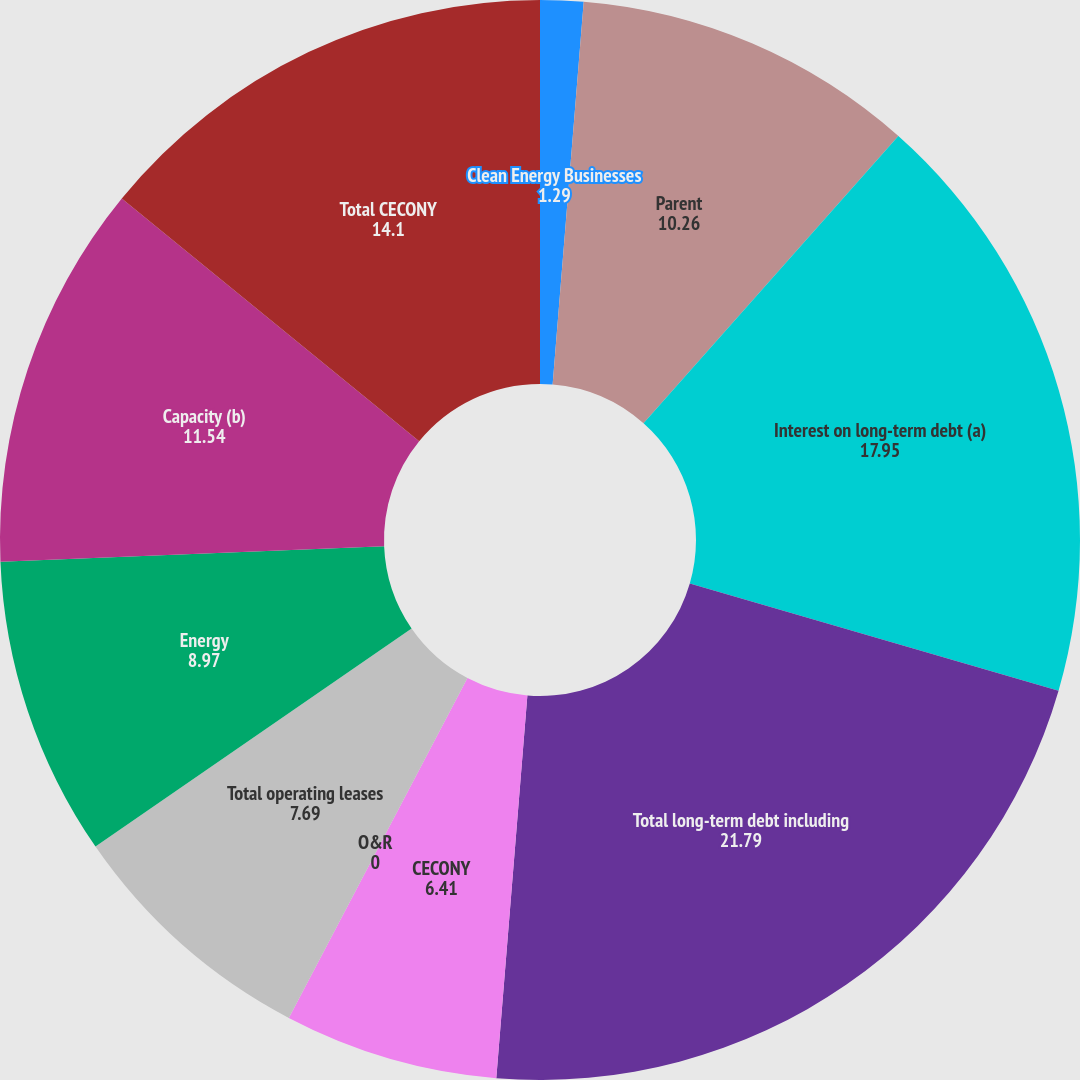<chart> <loc_0><loc_0><loc_500><loc_500><pie_chart><fcel>Clean Energy Businesses<fcel>Parent<fcel>Interest on long-term debt (a)<fcel>Total long-term debt including<fcel>CECONY<fcel>O&R<fcel>Total operating leases<fcel>Energy<fcel>Capacity (b)<fcel>Total CECONY<nl><fcel>1.29%<fcel>10.26%<fcel>17.95%<fcel>21.79%<fcel>6.41%<fcel>0.0%<fcel>7.69%<fcel>8.97%<fcel>11.54%<fcel>14.1%<nl></chart> 